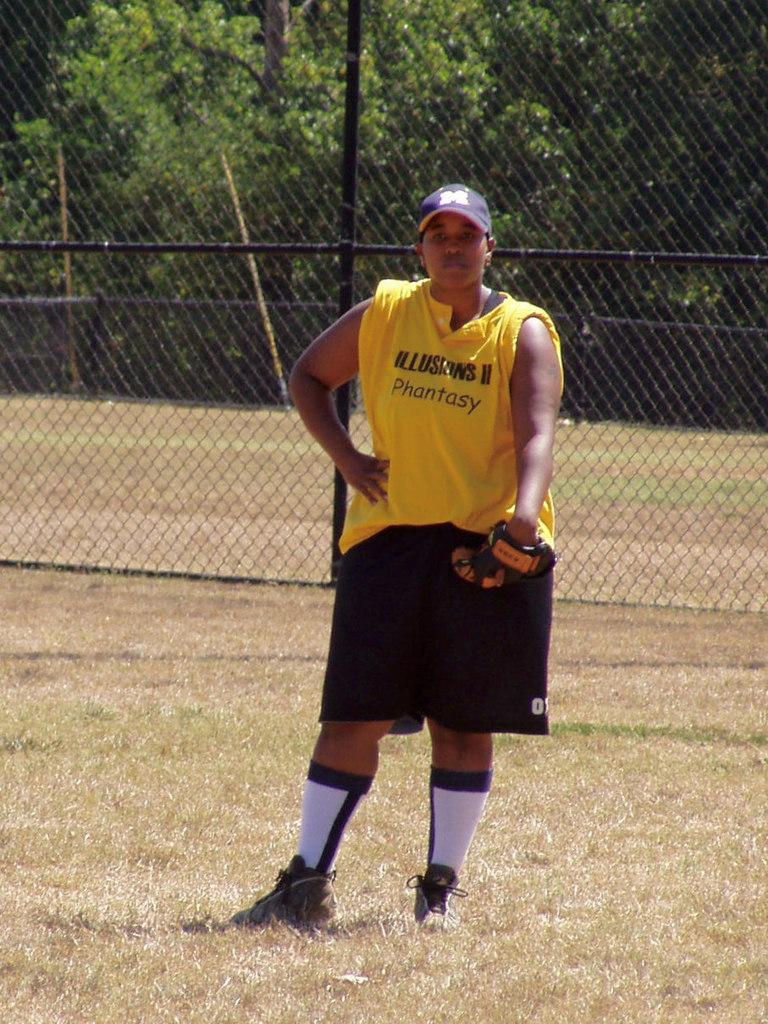<image>
Write a terse but informative summary of the picture. Girl wearing a yellow shirt which says "Phantasy" on it. 